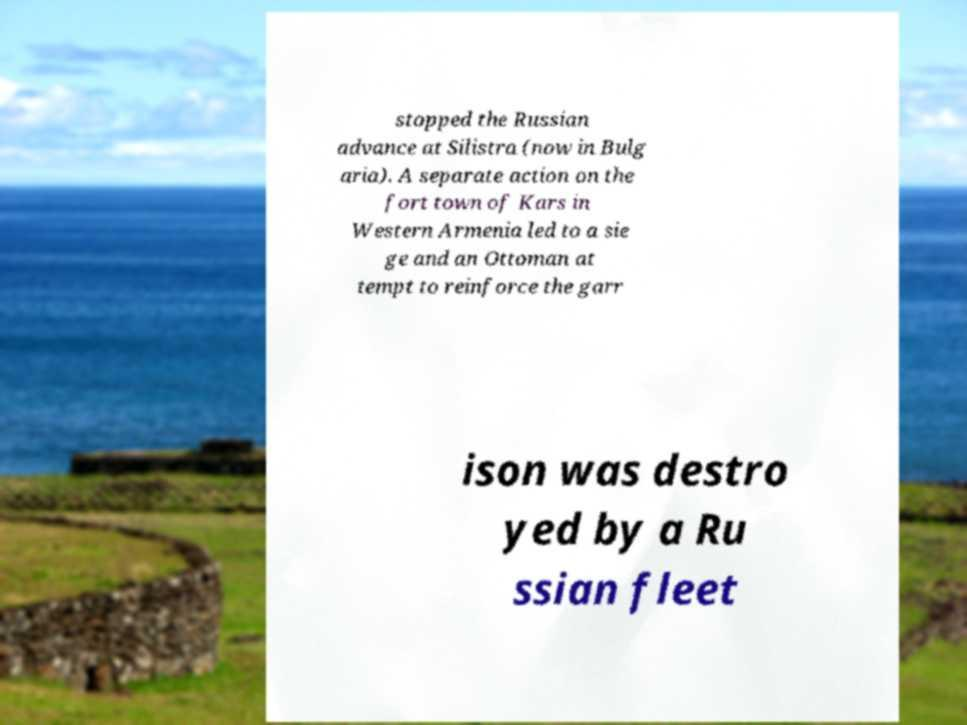Can you accurately transcribe the text from the provided image for me? stopped the Russian advance at Silistra (now in Bulg aria). A separate action on the fort town of Kars in Western Armenia led to a sie ge and an Ottoman at tempt to reinforce the garr ison was destro yed by a Ru ssian fleet 